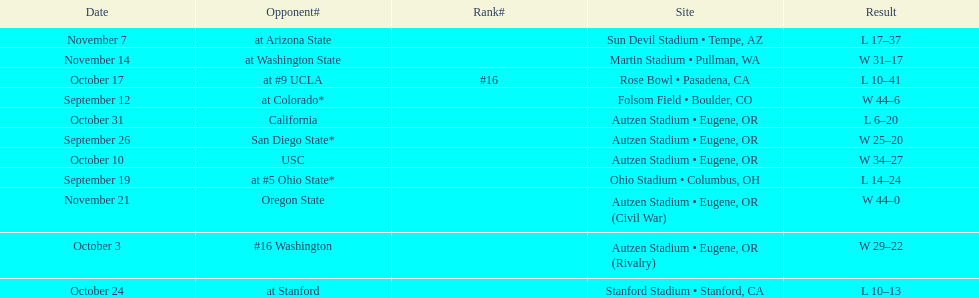Were the results of the game of november 14 above or below the results of the october 17 game? Above. 